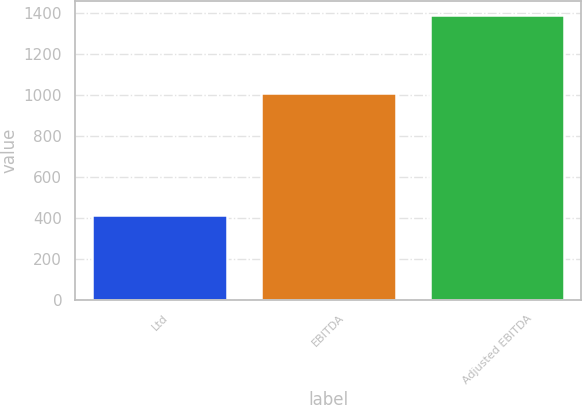Convert chart. <chart><loc_0><loc_0><loc_500><loc_500><bar_chart><fcel>Ltd<fcel>EBITDA<fcel>Adjusted EBITDA<nl><fcel>416.9<fcel>1011.6<fcel>1389.9<nl></chart> 